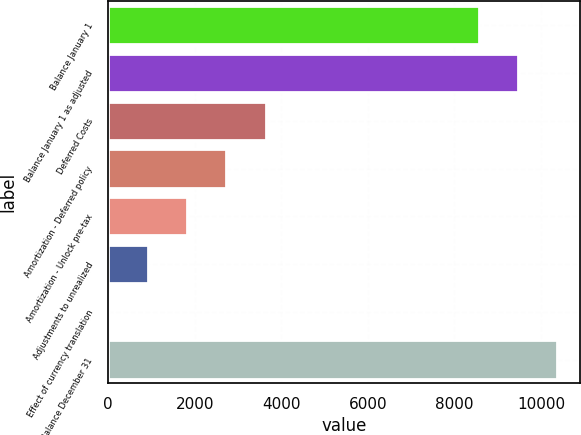Convert chart. <chart><loc_0><loc_0><loc_500><loc_500><bar_chart><fcel>Balance January 1<fcel>Balance January 1 as adjusted<fcel>Deferred Costs<fcel>Amortization - Deferred policy<fcel>Amortization - Unlock pre-tax<fcel>Adjustments to unrealized<fcel>Effect of currency translation<fcel>Balance December 31<nl><fcel>8568<fcel>9473.6<fcel>3637.4<fcel>2731.8<fcel>1826.2<fcel>920.6<fcel>15<fcel>10379.2<nl></chart> 